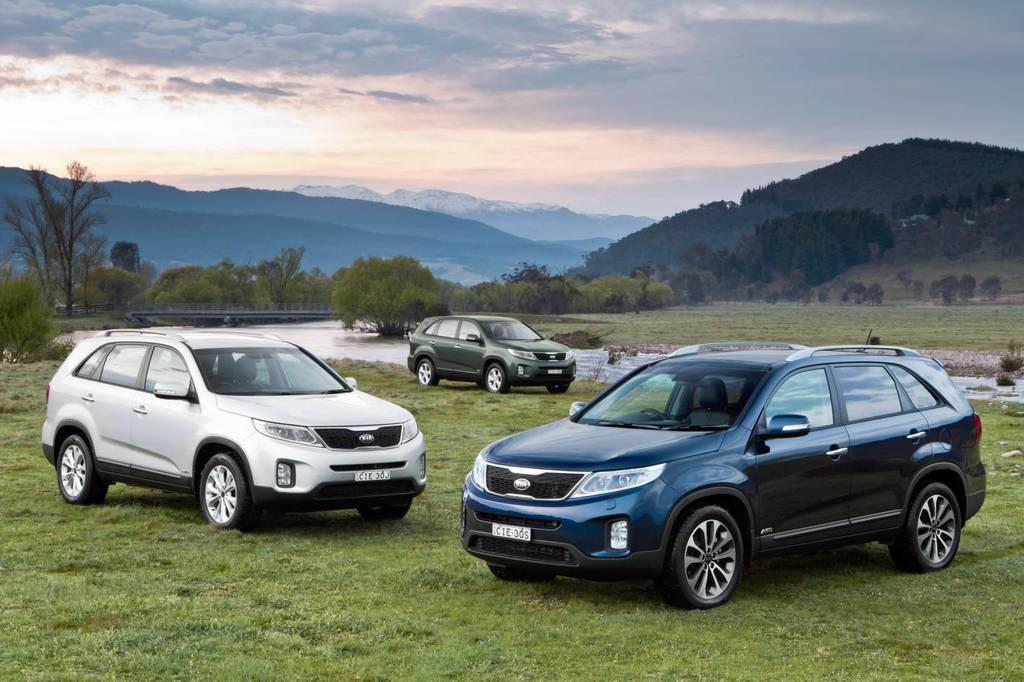How many cars are in the image? There are three cars in the image. What is on the ground in the image? There is grass on the ground. What else can be seen in the image besides the cars and grass? There is water, trees, a bridge, hills, and the sky visible in the image. What is the condition of the sky in the image? The sky is visible in the image, and clouds are present. What type of mint can be seen growing near the bridge in the image? There is no mint visible in the image; it features a landscape with cars, grass, water, trees, a bridge, hills, and the sky. How many gold rabbits are hopping on the hills in the image? There are no rabbits, gold or otherwise, present in the image. 